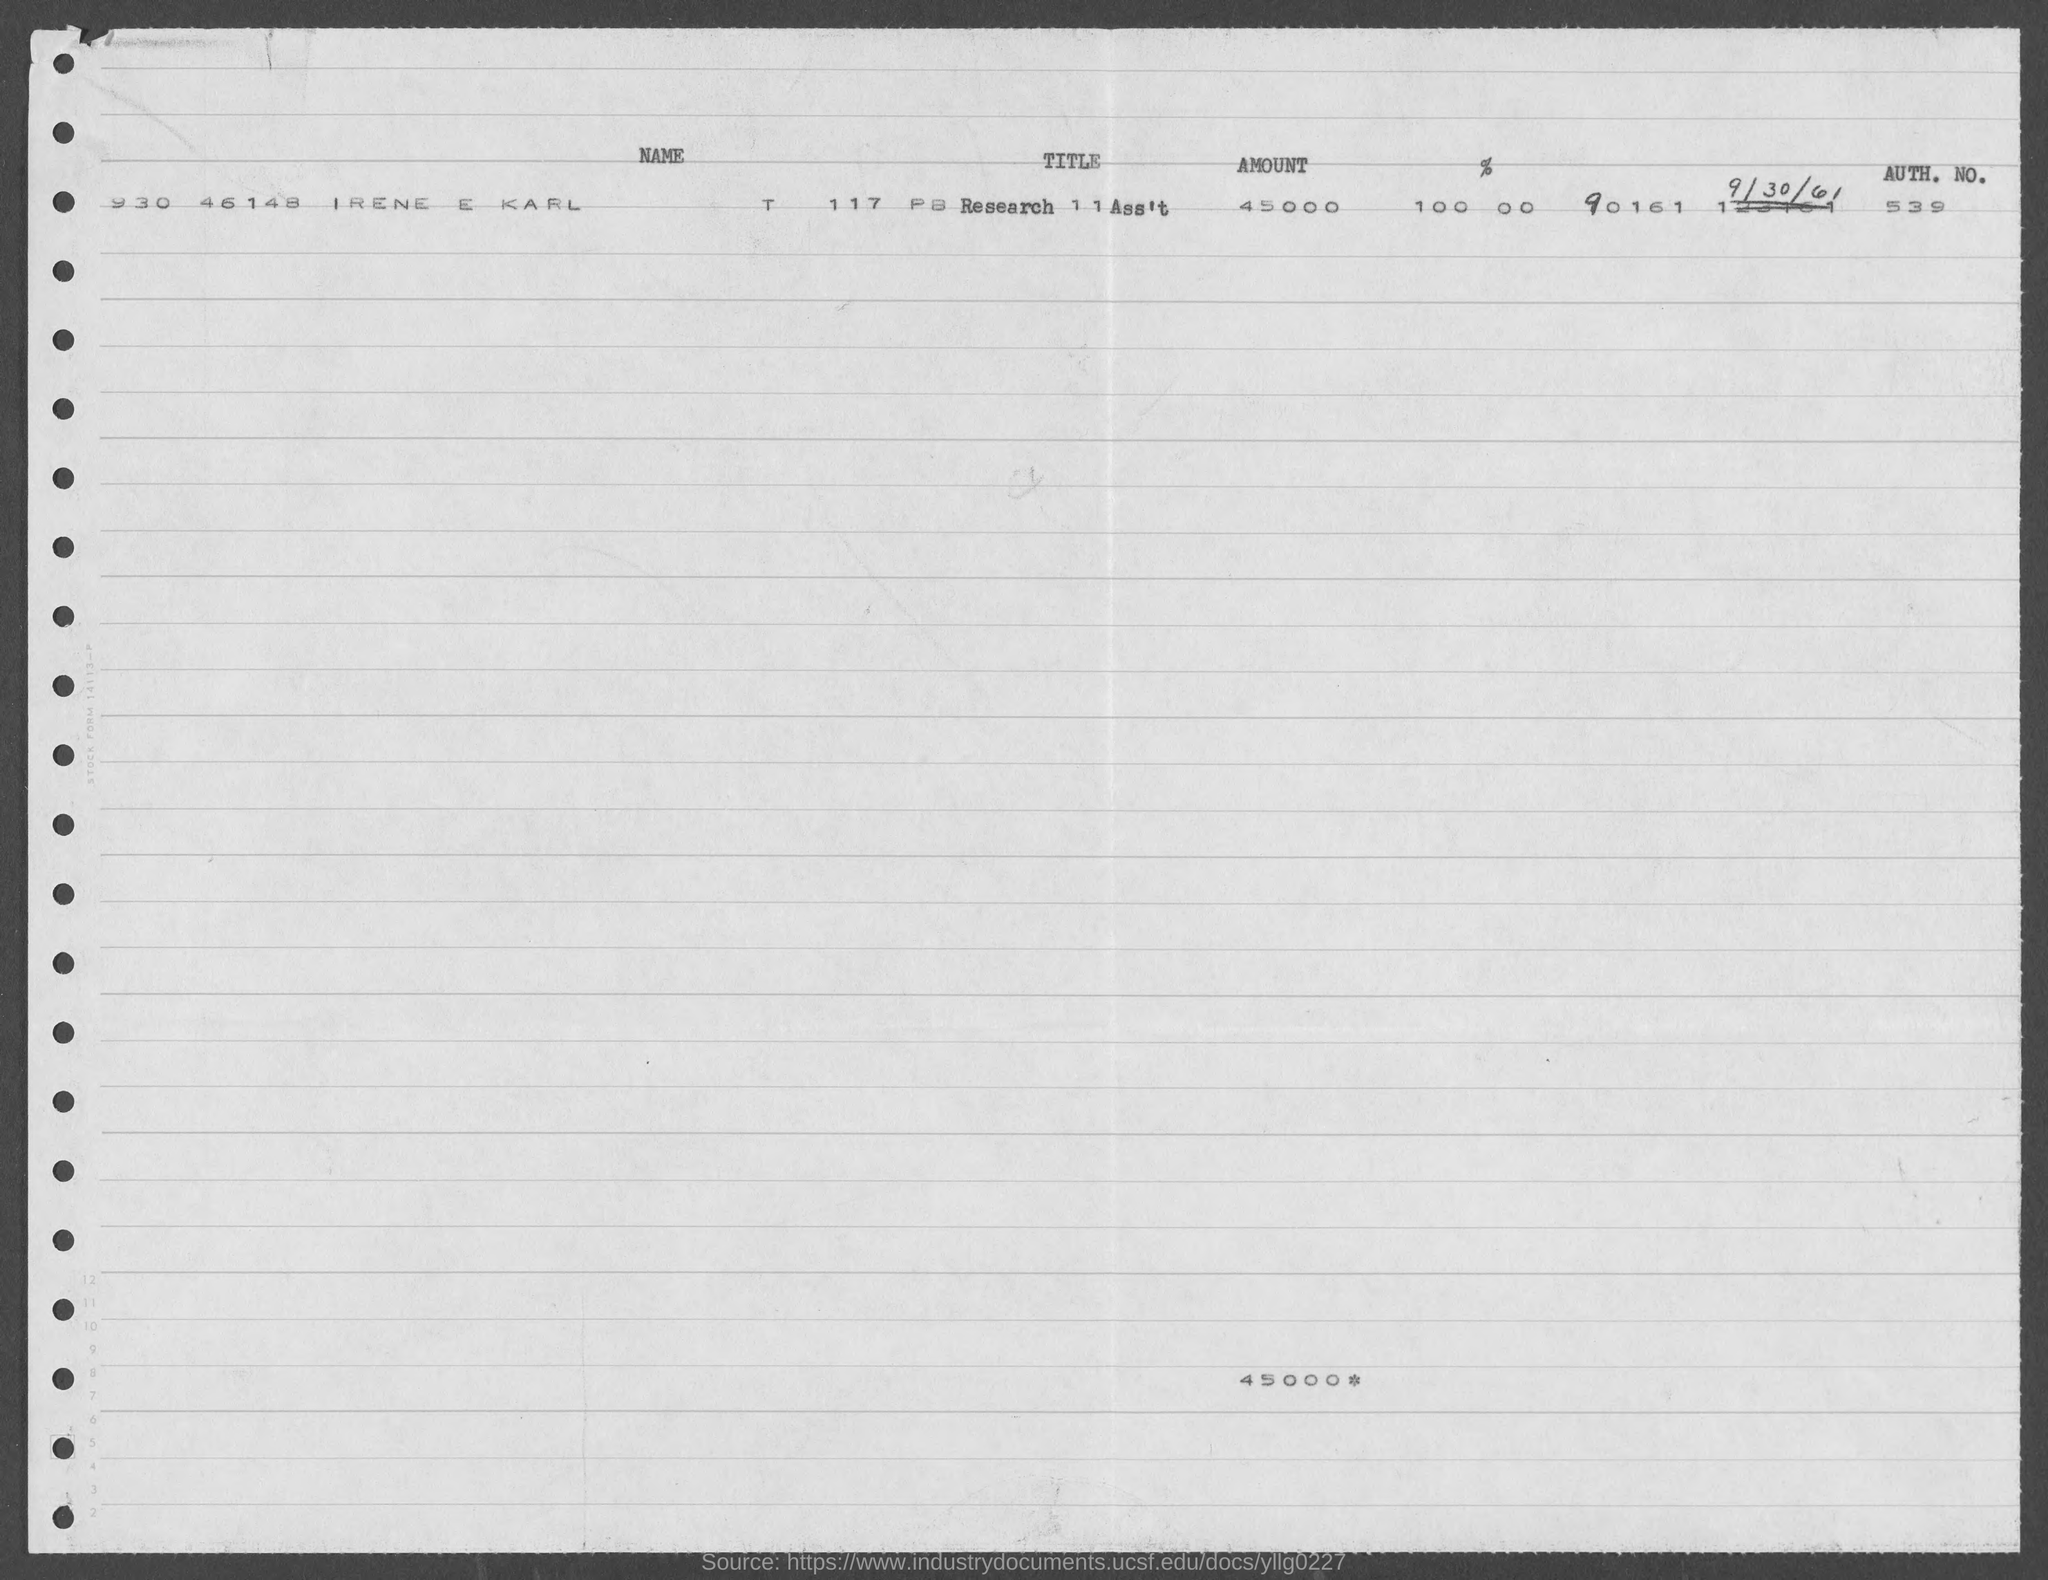What is the AUTH. NO. ?
Your answer should be compact. 539. How much amount is mentioned in the document?
Your response must be concise. 45000. 